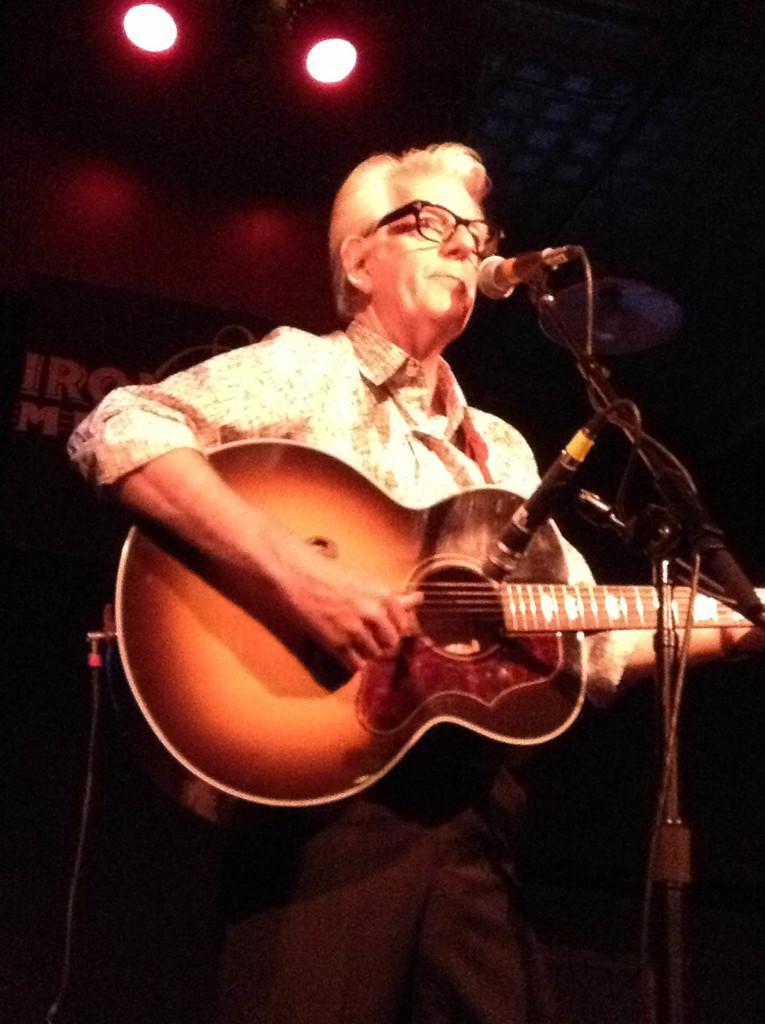Can you describe this image briefly? This picture shows a man playing a guitar in his hands and wearing spectacles. He is singing in front of a mic. In the background there is a wall and some lights here. 